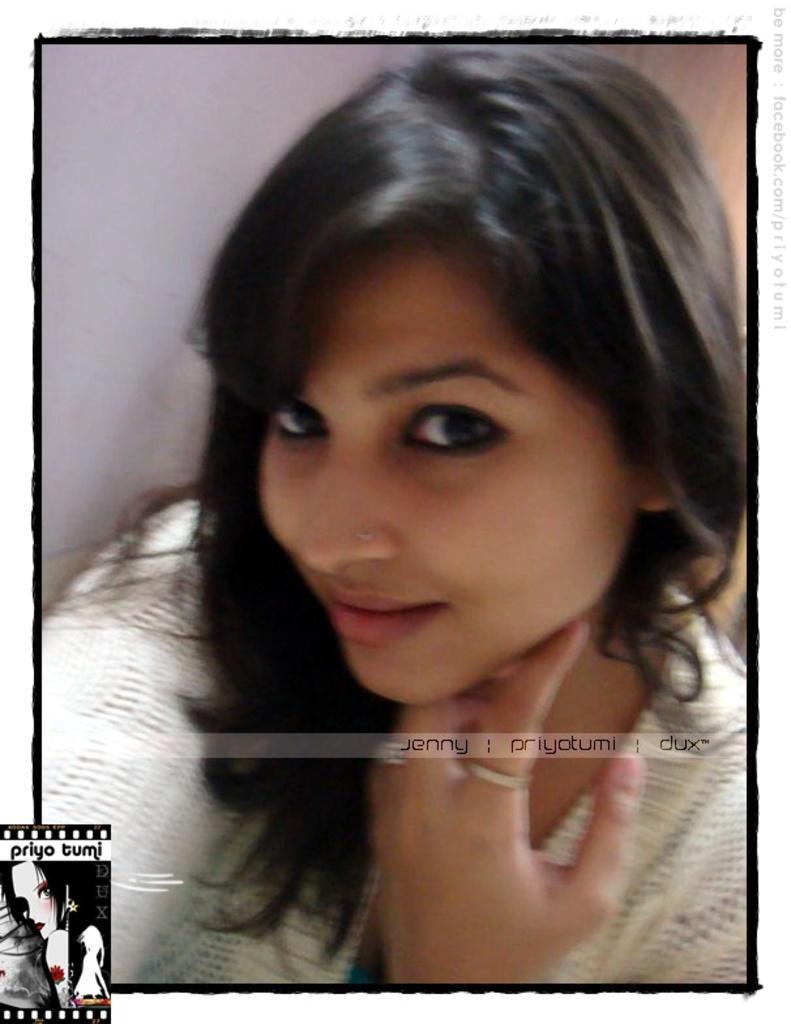Describe this image in one or two sentences. This is the woman smiling. She wore a white color dress. I can see the watermarks on the image. I think this is the wall. 